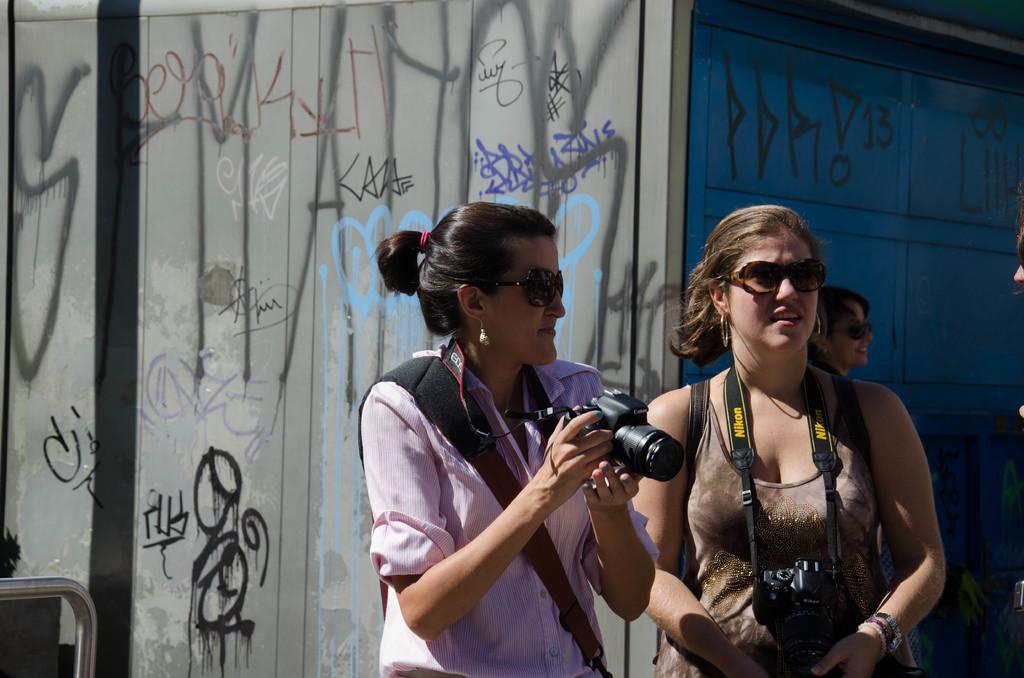Could you give a brief overview of what you see in this image? In this image there are two people holding the camera. Behind them there is a wall with a painting on it. On the left side of the image there is a metal rod. On the right side of the image there are a few other people. 